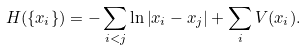Convert formula to latex. <formula><loc_0><loc_0><loc_500><loc_500>H ( \{ x _ { i } \} ) = - \sum _ { i < j } \ln \left | x _ { i } - x _ { j } \right | + \sum _ { i } V ( x _ { i } ) .</formula> 